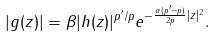Convert formula to latex. <formula><loc_0><loc_0><loc_500><loc_500>| g ( z ) | = \beta | h ( z ) | ^ { { p ^ { \prime } } / p } e ^ { - \frac { \alpha ( p ^ { \prime } - p ) } { 2 p } | z | ^ { 2 } } .</formula> 